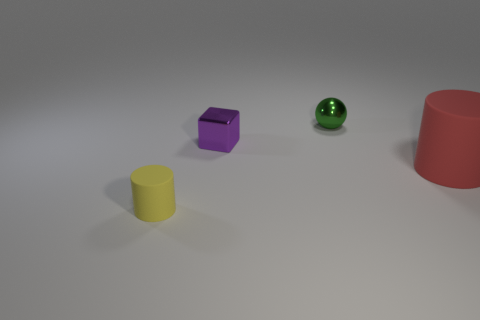Add 4 small cyan spheres. How many objects exist? 8 Subtract all balls. How many objects are left? 3 Add 4 tiny green shiny spheres. How many tiny green shiny spheres are left? 5 Add 3 small green balls. How many small green balls exist? 4 Subtract 0 brown cylinders. How many objects are left? 4 Subtract all tiny gray cubes. Subtract all big rubber cylinders. How many objects are left? 3 